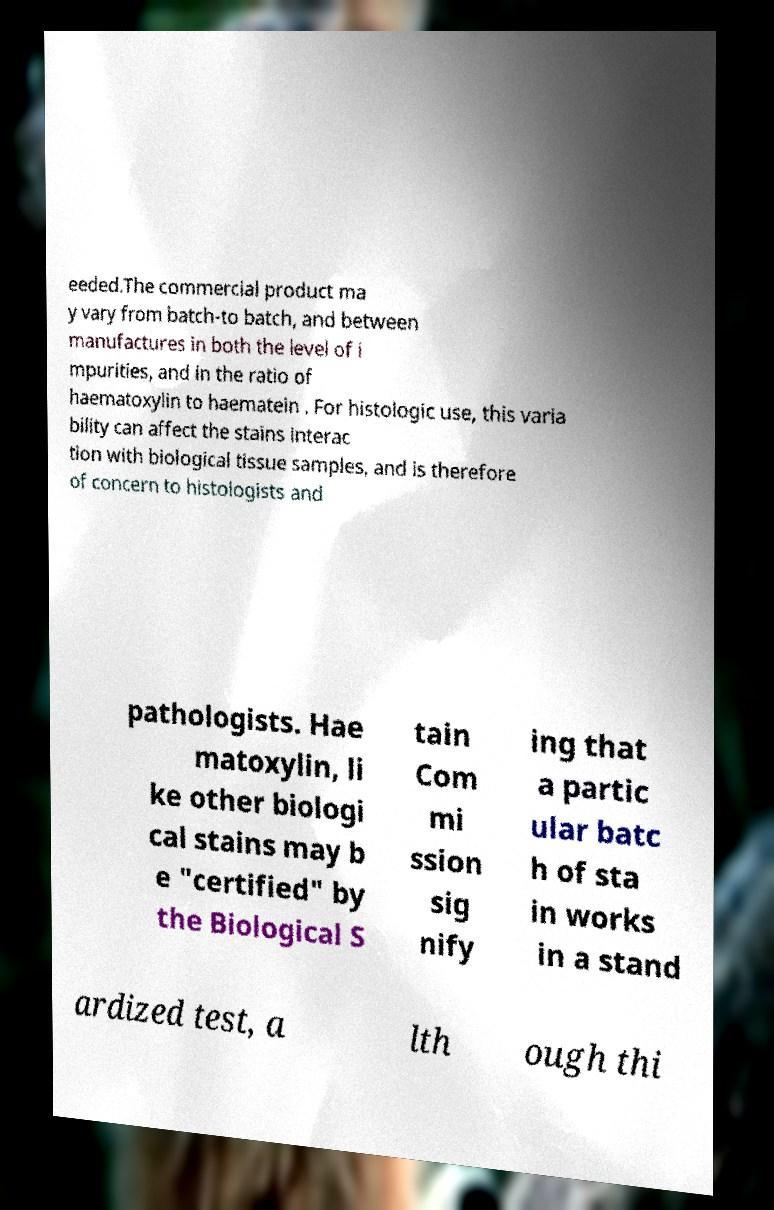What messages or text are displayed in this image? I need them in a readable, typed format. eeded.The commercial product ma y vary from batch-to batch, and between manufactures in both the level of i mpurities, and in the ratio of haematoxylin to haematein . For histologic use, this varia bility can affect the stains interac tion with biological tissue samples, and is therefore of concern to histologists and pathologists. Hae matoxylin, li ke other biologi cal stains may b e "certified" by the Biological S tain Com mi ssion sig nify ing that a partic ular batc h of sta in works in a stand ardized test, a lth ough thi 